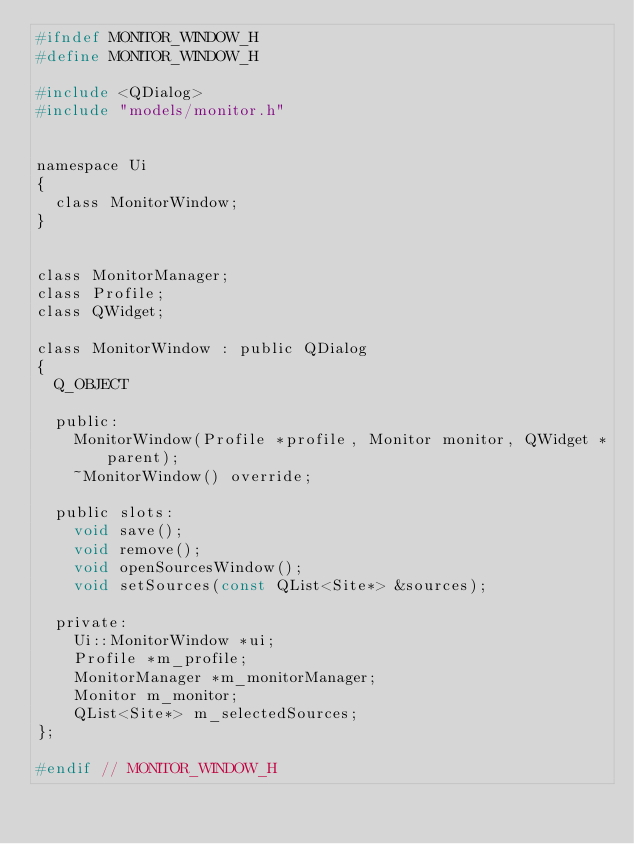<code> <loc_0><loc_0><loc_500><loc_500><_C_>#ifndef MONITOR_WINDOW_H
#define MONITOR_WINDOW_H

#include <QDialog>
#include "models/monitor.h"


namespace Ui
{
	class MonitorWindow;
}


class MonitorManager;
class Profile;
class QWidget;

class MonitorWindow : public QDialog
{
	Q_OBJECT

	public:
		MonitorWindow(Profile *profile, Monitor monitor, QWidget *parent);
		~MonitorWindow() override;

	public slots:
		void save();
		void remove();
		void openSourcesWindow();
		void setSources(const QList<Site*> &sources);

	private:
		Ui::MonitorWindow *ui;
		Profile *m_profile;
		MonitorManager *m_monitorManager;
		Monitor m_monitor;
		QList<Site*> m_selectedSources;
};

#endif // MONITOR_WINDOW_H
</code> 